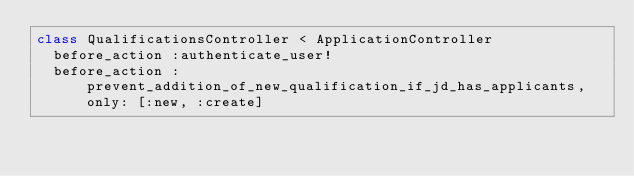<code> <loc_0><loc_0><loc_500><loc_500><_Ruby_>class QualificationsController < ApplicationController
  before_action :authenticate_user!
  before_action :prevent_addition_of_new_qualification_if_jd_has_applicants, only: [:new, :create]</code> 